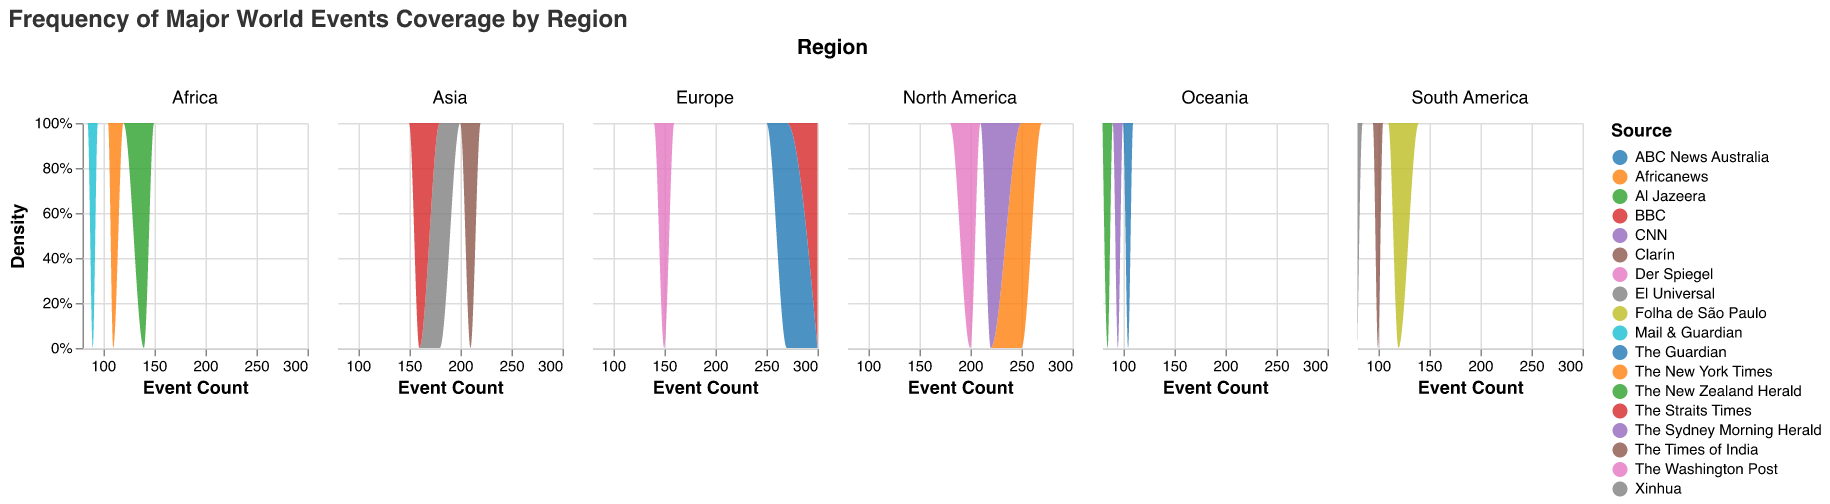Which region has the highest event count for a source, and which source is it? By examining the density plots, we see that the highest event count under any source is in Europe for BBC, which is at 300 events.
Answer: Europe, BBC Which source in North America has the highest event count? By analyzing the density plot for North America, the source with the highest event count is The New York Times, which has 250 events.
Answer: The New York Times How does the event count range in Africa compare to that of Oceania? By comparing the density plots for Africa and Oceania, we observe that Africa’s event counts range from 90 to 140, while Oceania's range from 85 to 105. Hence, Africa has a broader range.
Answer: Africa has a broader range Which source in Asia has the least event count? Observing the density plot for Asia, the least event count is 160, covered by The Straits Times.
Answer: The Straits Times Compare the event count for Africa's Al Jazeera and Mail & Guardian. In the density plot for Africa, Al Jazeera has an event count of 140, while Mail & Guardian has an event count of 90. Therefore, Al Jazeera has a higher event count than Mail & Guardian by 50.
Answer: Al Jazeera has higher count by 50 Calculate the average event count for the three sources in South America. Adding up the event counts for South American sources (120, 80, and 100) and dividing by 3, we get an average of (120 + 80 + 100) / 3 = 100.
Answer: 100 Which region has the most sources with an event count higher than 200? By examining each region's plot, North America has three sources, all of which have an event count higher than 200 (The New York Times, CNN, The Washington Post). Therefore, North America leads in this criterion.
Answer: North America Do any regions have sources that converge at the same event count? By inspecting the density plots, Oceania has two sources close in event counts: The Sydney Morning Herald and ABC News Australia, which are very close to each other at around 95 and 105, respectively.
Answer: Yes, Oceania What is the difference between the highest and lowest event counts within Europe? The highest event count in Europe is 300 (BBC), and the lowest is 150 (Der Spiegel). Therefore, the difference is 300 - 150 = 150.
Answer: 150 